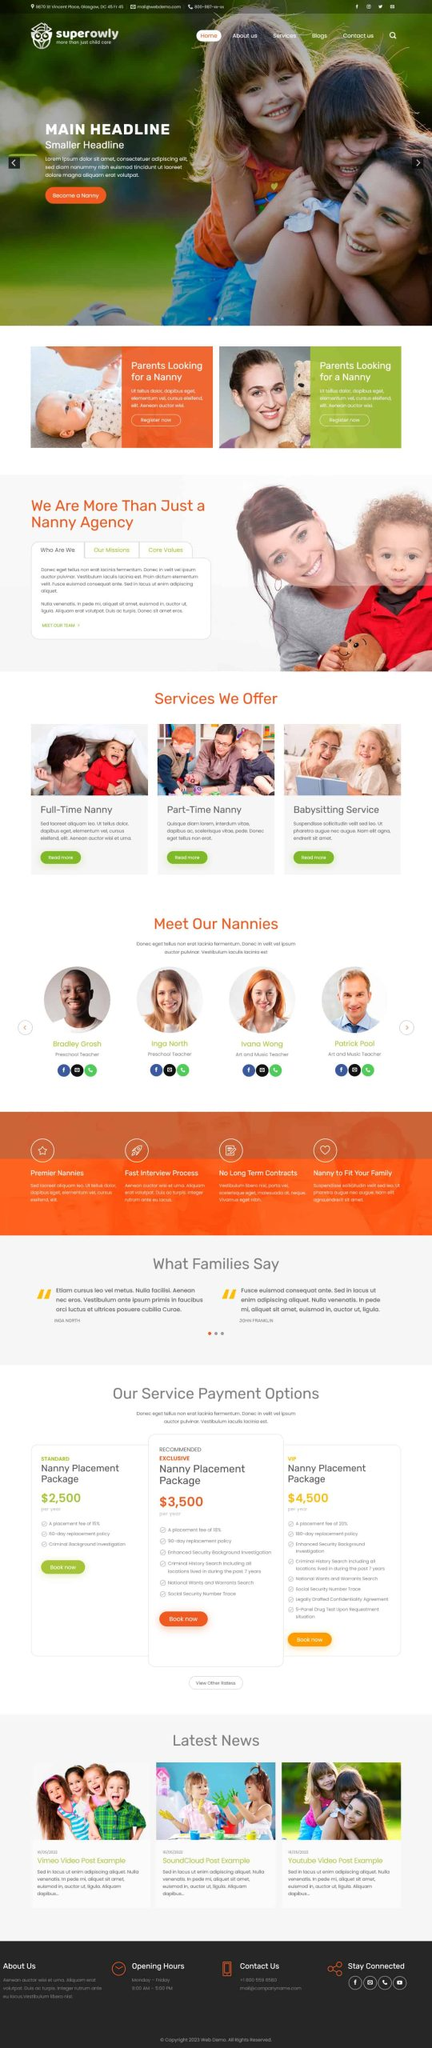Liệt kê 5 ngành nghề, lĩnh vực phù hợp với website này, phân cách các màu sắc bằng dấu phẩy. Chỉ trả về kết quả, phân cách bằng dấy phẩy
 Giáo dục, Y tế, Dịch vụ chăm sóc trẻ em, Tư vấn gia đình, Dịch vụ gia đình 